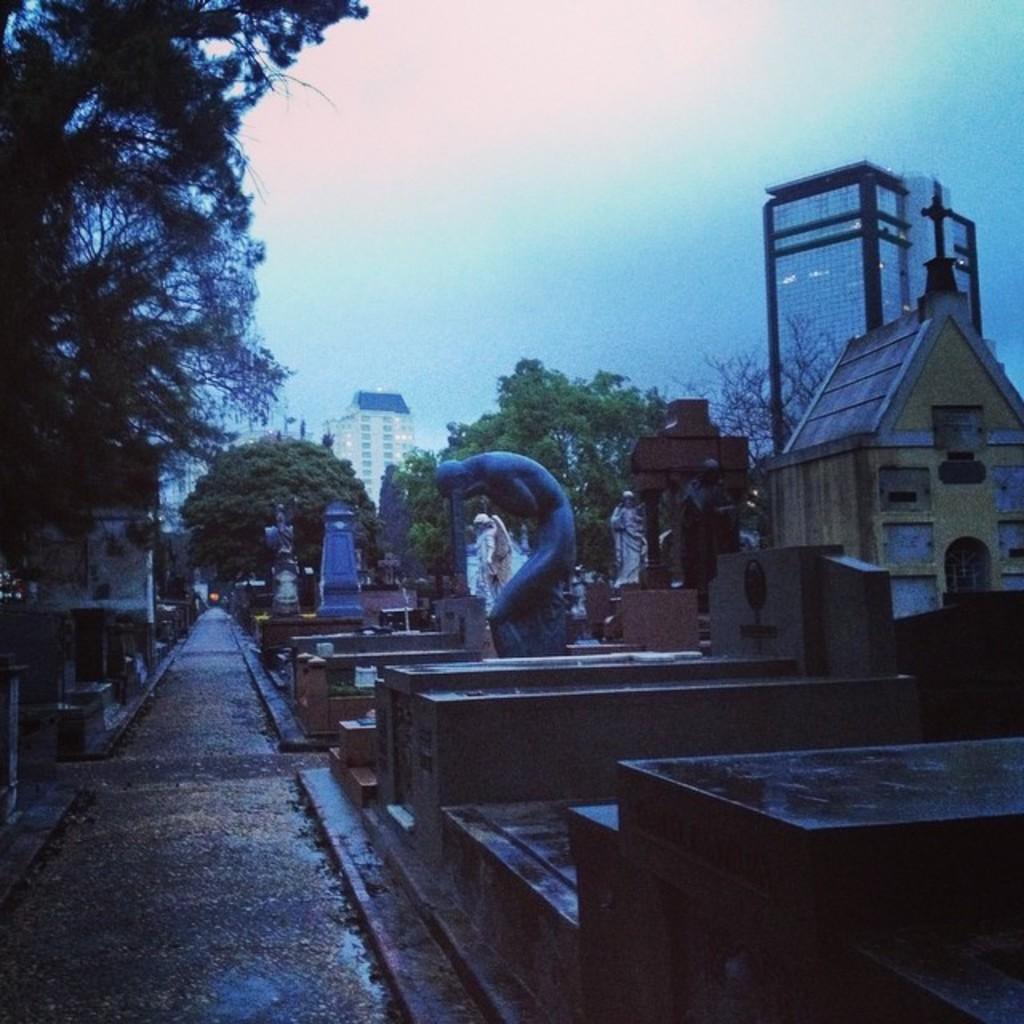In one or two sentences, can you explain what this image depicts? In front of the image there are statues and some other structures. Behind them there are trees, buildings. At the top of the image there is sky. 